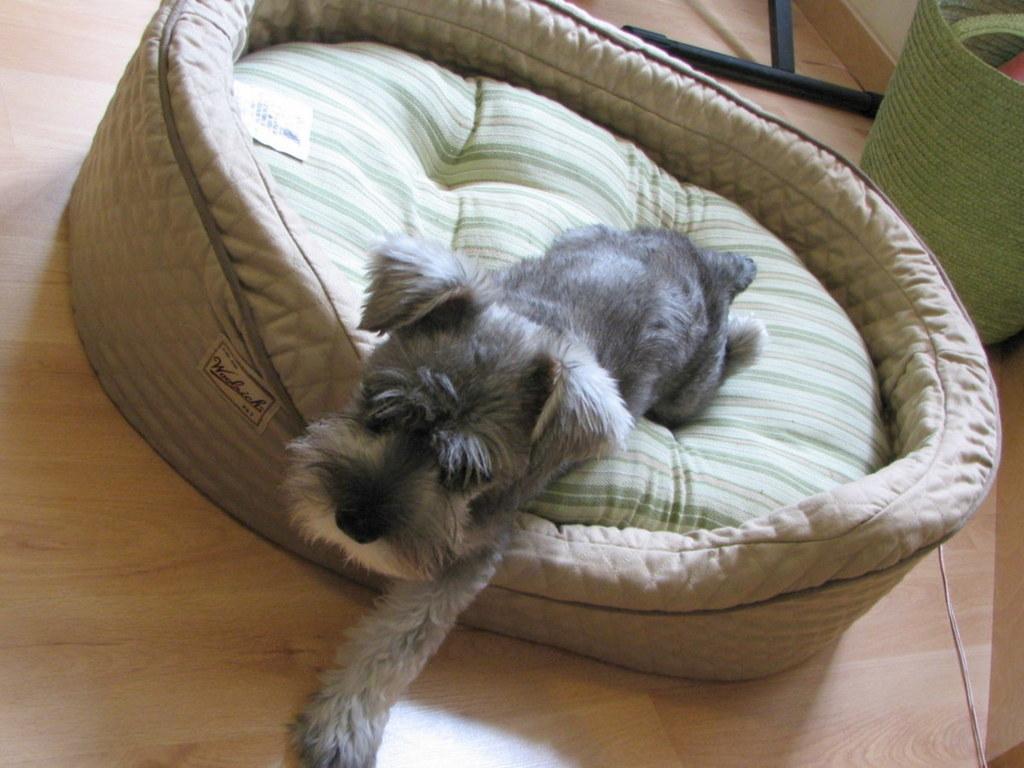In one or two sentences, can you explain what this image depicts? In this image I can see a dog in gray and white color, and the dog is on the bed which is in cream color. Background I can see a green color mat and the floor is in cream color. 